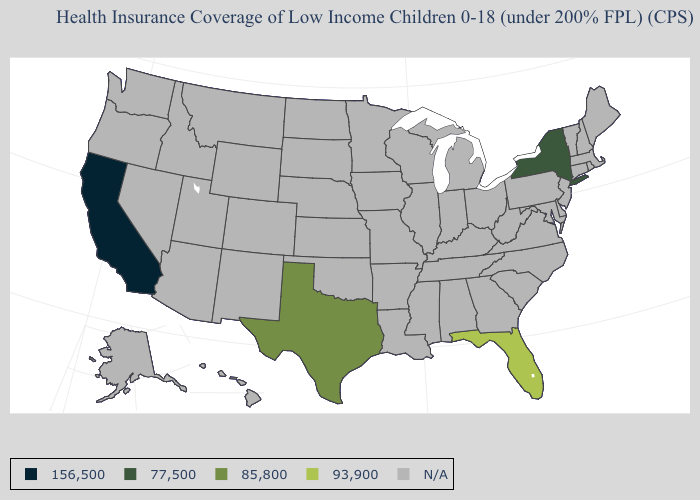What is the value of Virginia?
Write a very short answer. N/A. What is the value of Missouri?
Be succinct. N/A. Which states have the highest value in the USA?
Keep it brief. Florida. Name the states that have a value in the range 156,500?
Quick response, please. California. What is the lowest value in states that border New Mexico?
Answer briefly. 85,800. What is the lowest value in the Northeast?
Short answer required. 77,500. Which states have the lowest value in the USA?
Short answer required. California. Name the states that have a value in the range 93,900?
Quick response, please. Florida. How many symbols are there in the legend?
Write a very short answer. 5. Name the states that have a value in the range N/A?
Short answer required. Alabama, Alaska, Arizona, Arkansas, Colorado, Connecticut, Delaware, Georgia, Hawaii, Idaho, Illinois, Indiana, Iowa, Kansas, Kentucky, Louisiana, Maine, Maryland, Massachusetts, Michigan, Minnesota, Mississippi, Missouri, Montana, Nebraska, Nevada, New Hampshire, New Jersey, New Mexico, North Carolina, North Dakota, Ohio, Oklahoma, Oregon, Pennsylvania, Rhode Island, South Carolina, South Dakota, Tennessee, Utah, Vermont, Virginia, Washington, West Virginia, Wisconsin, Wyoming. Does New York have the highest value in the USA?
Write a very short answer. No. 